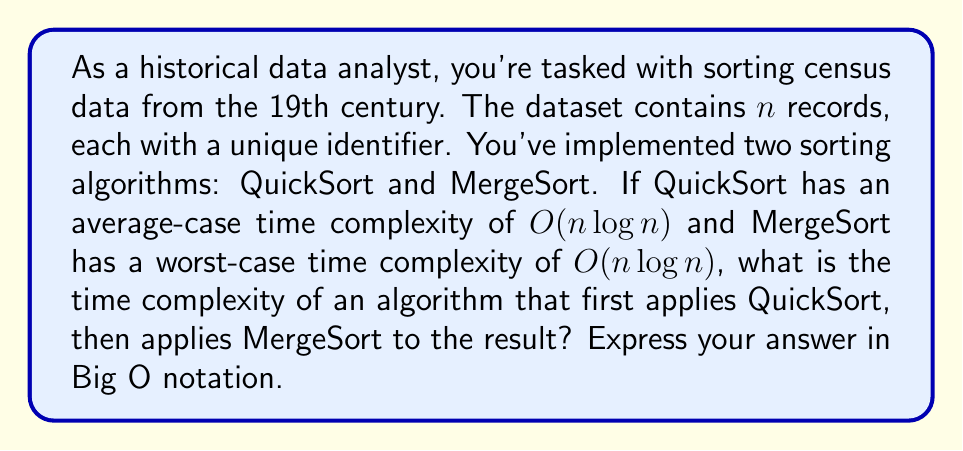Help me with this question. To solve this problem, we need to analyze the time complexity of the combined algorithm:

1. First, QuickSort is applied to the dataset of $n$ records. The average-case time complexity of QuickSort is $O(n \log n)$.

2. After QuickSort completes, MergeSort is applied to the already sorted dataset. The worst-case time complexity of MergeSort is also $O(n \log n)$.

3. When we have two algorithms performed sequentially, we add their time complexities.

   Total Time Complexity = $O(n \log n) + O(n \log n)$

4. In Big O notation, we can simplify this sum:
   
   $O(n \log n) + O(n \log n) = O(2n \log n)$

5. Constants are dropped in Big O notation, so we can further simplify:

   $O(2n \log n) = O(n \log n)$

Therefore, despite applying two $O(n \log n)$ algorithms sequentially, the overall time complexity remains $O(n \log n)$.

This result is important for historical data analysis, as it shows that adding an additional sorting step (perhaps for verification or to meet specific data format requirements) does not increase the asymptotic time complexity of the process.
Answer: $O(n \log n)$ 